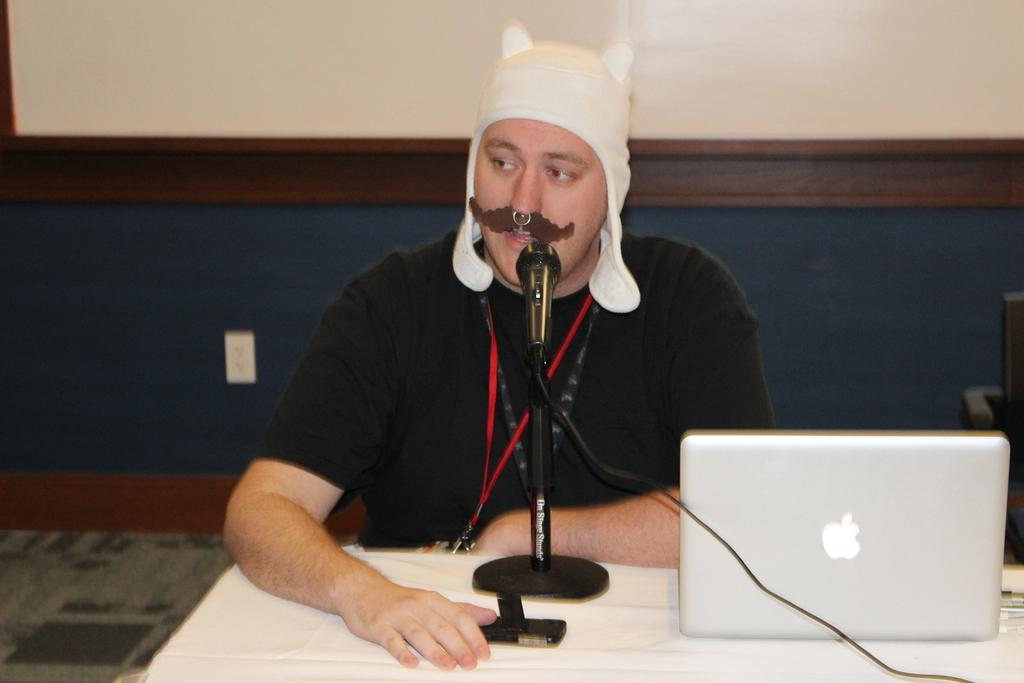What object is located on the table in the image? There is a mobile on the table in the image. What other objects can be seen on the table? There is a mic and a laptop on the table in the image. Who is present in the image? There is a person in front of the table in the image. What colors are present in the background of the image? The background includes a white wall, a brown wall, and a blue wall in the image. What type of polish is being applied to the person's nails in the image? There is no indication in the image that the person's nails are being polished, so it cannot be determined from the picture. 